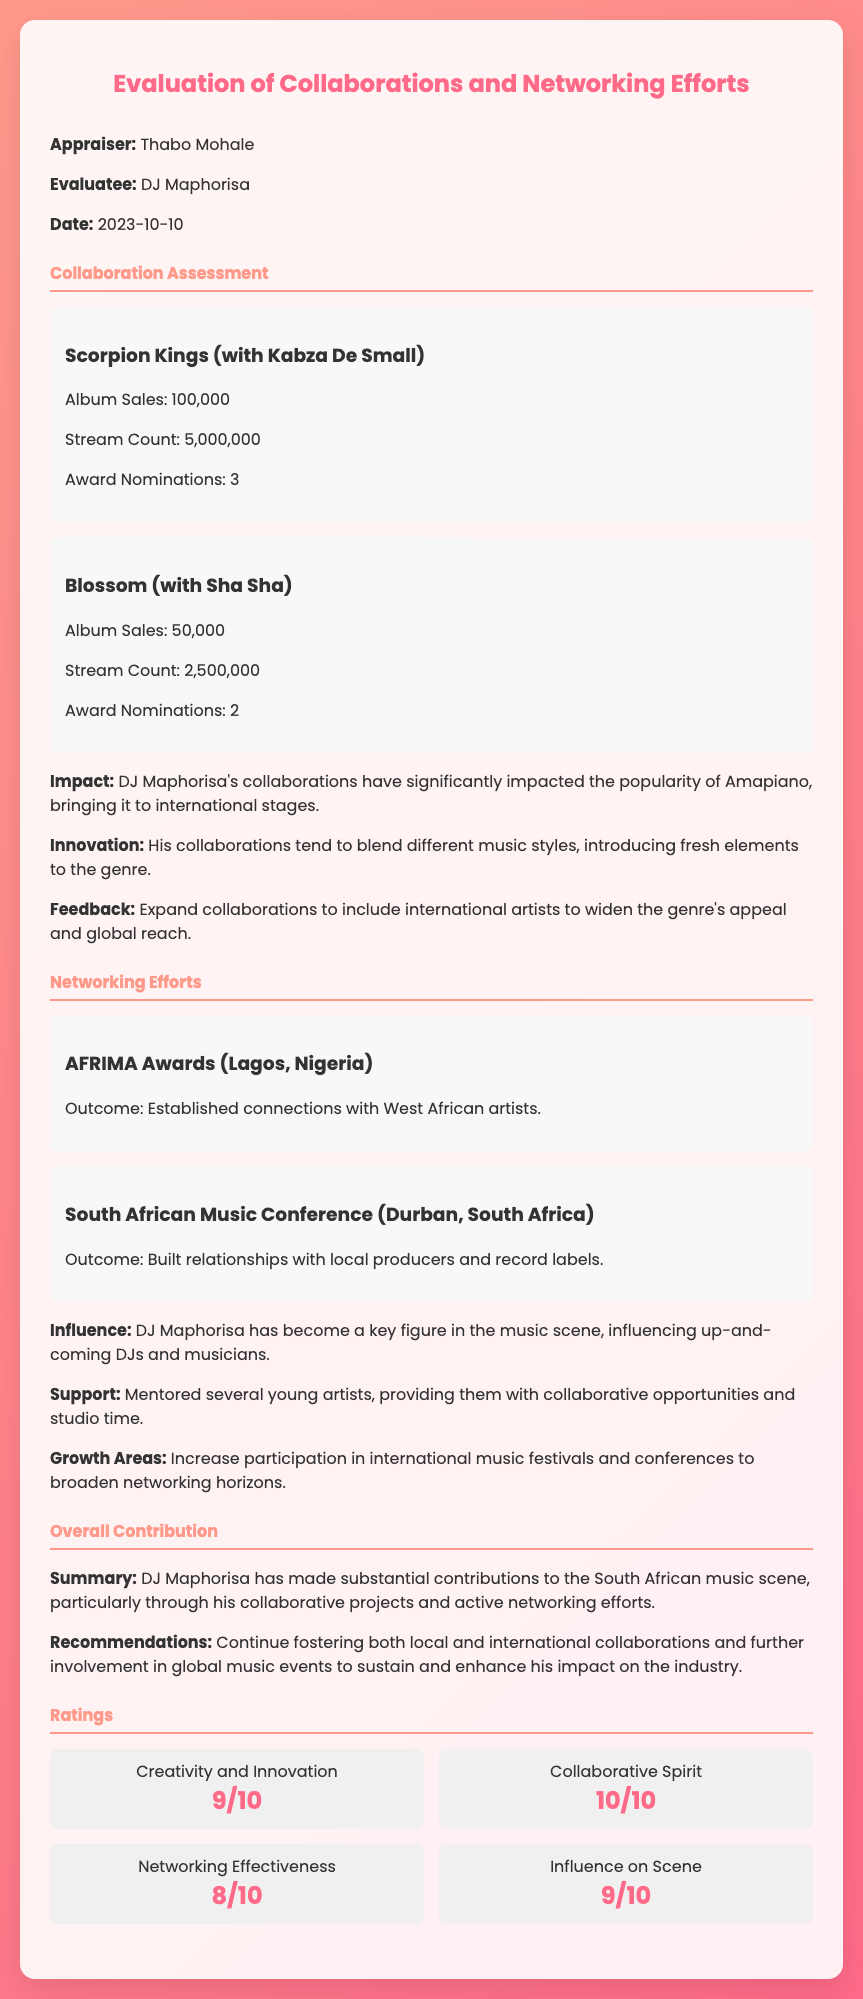What is the appraiser's name? The appraiser's name is mentioned in the section that identifies the individuals in the appraisal, specifically under "Appraiser."
Answer: Thabo Mohale What is the date of the appraisal? The date is provided in the section where the appraiser and evaluatee details are listed, specifically under "Date."
Answer: 2023-10-10 How many album sales did the collaboration with Kabza De Small achieve? The number of album sales is stated under the collaboration assessment for Scorpion Kings.
Answer: 100,000 What is the stream count for the collaboration "Blossom"? The stream count is detailed in the collaboration assessment for the track "Blossom."
Answer: 2,500,000 What is the outcome of the AFRIMA Awards networking event? The outcome is listed under the networking efforts section specifically for the AFRIMA Awards event.
Answer: Established connections with West African artists How many award nominations did the collaboration "Scorpion Kings" receive? The number of award nominations is given under the specific collaboration assessment for the "Scorpion Kings."
Answer: 3 What rating did DJ Maphorisa receive for Networking Effectiveness? The rating is included in the section dedicated to ratings and appears under the specific criterion of Networking Effectiveness.
Answer: 8/10 What is one of the recommendations provided in the overall contribution section? The specific recommendations are stated in the section summarizing the contributions of DJ Maphorisa.
Answer: Continue fostering both local and international collaborations 